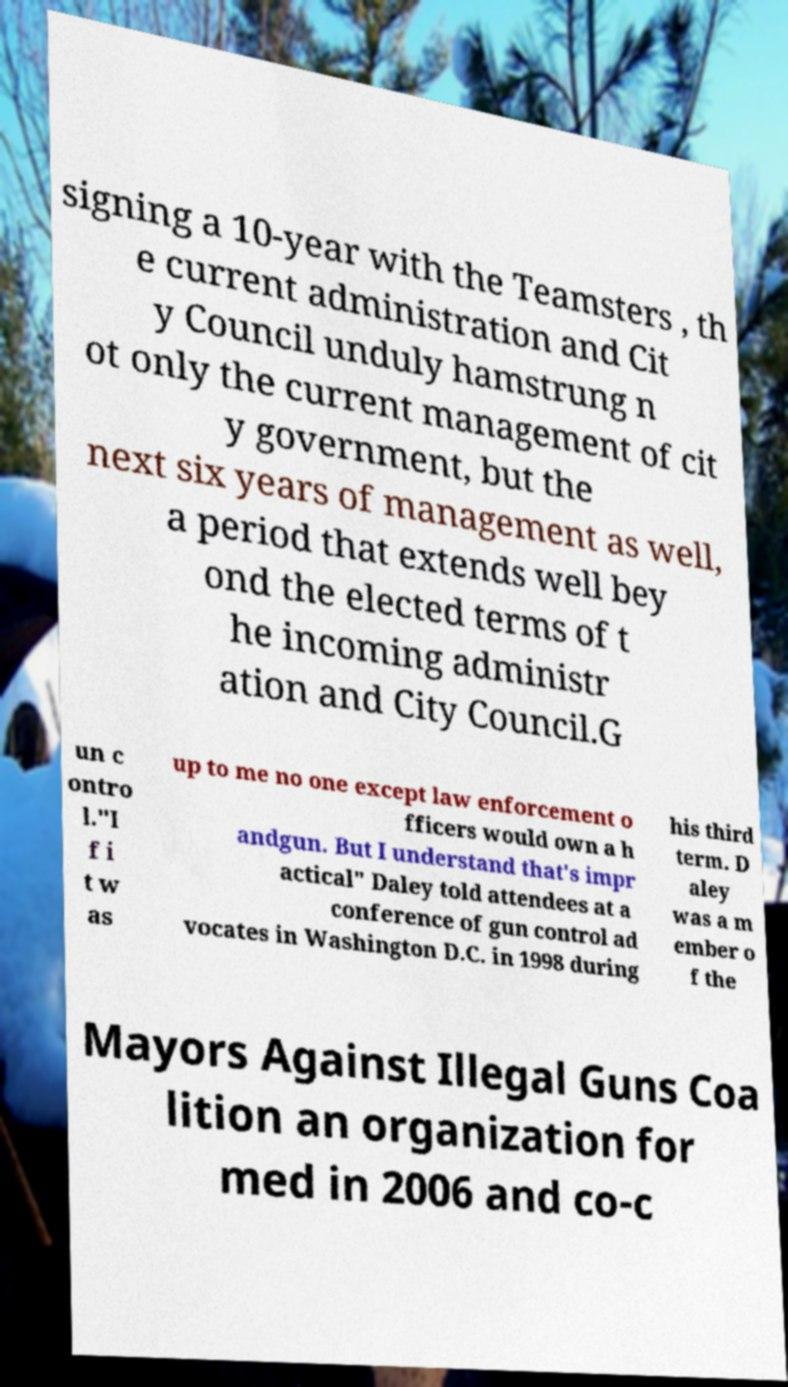There's text embedded in this image that I need extracted. Can you transcribe it verbatim? signing a 10-year with the Teamsters , th e current administration and Cit y Council unduly hamstrung n ot only the current management of cit y government, but the next six years of management as well, a period that extends well bey ond the elected terms of t he incoming administr ation and City Council.G un c ontro l."I f i t w as up to me no one except law enforcement o fficers would own a h andgun. But I understand that's impr actical" Daley told attendees at a conference of gun control ad vocates in Washington D.C. in 1998 during his third term. D aley was a m ember o f the Mayors Against Illegal Guns Coa lition an organization for med in 2006 and co-c 